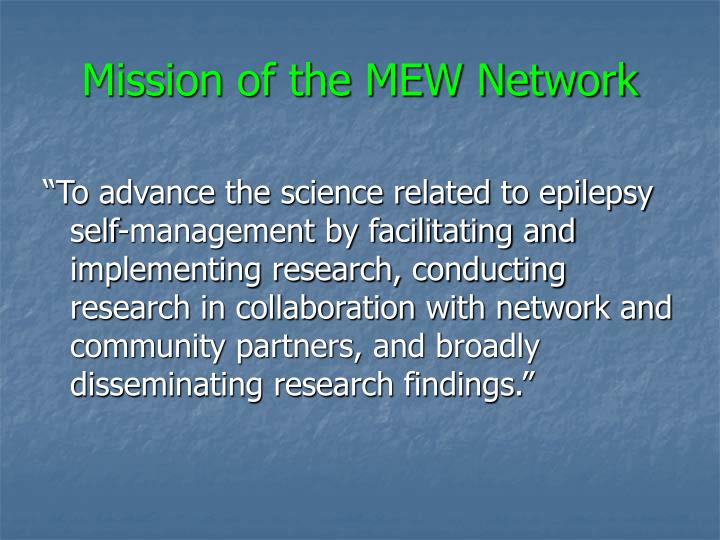Could you explain how the MEW Network's research initiatives might impact individuals with epilepsy? The research initiatives of the MEW Network are designed to directly impact individuals with epilepsy by developing and refining self-management strategies. These projects could lead to new insights into the best practices for managing daily life with epilepsy, potentially improving individual outcomes in terms of health stability, psychological well-being, and overall life satisfaction. 